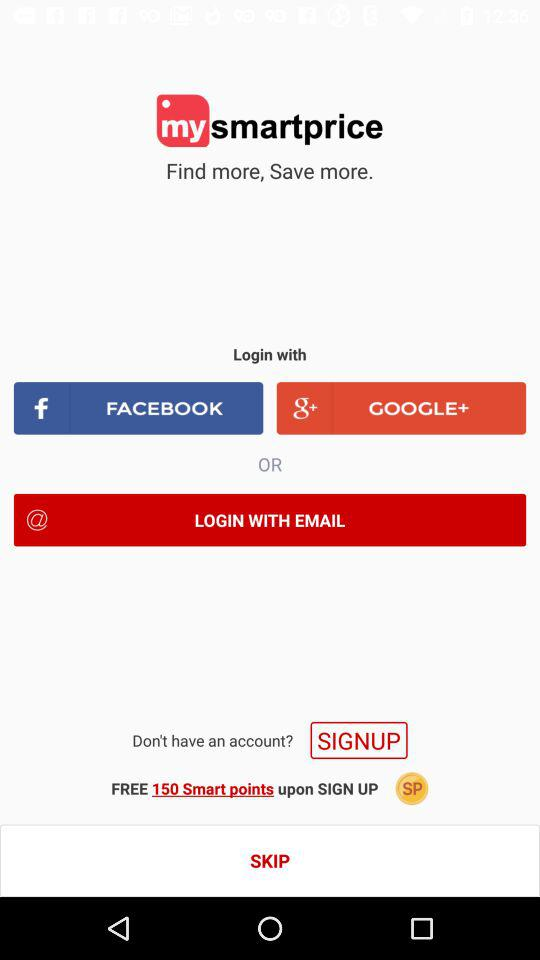What is the application name? The application name is "mysmartprice". 